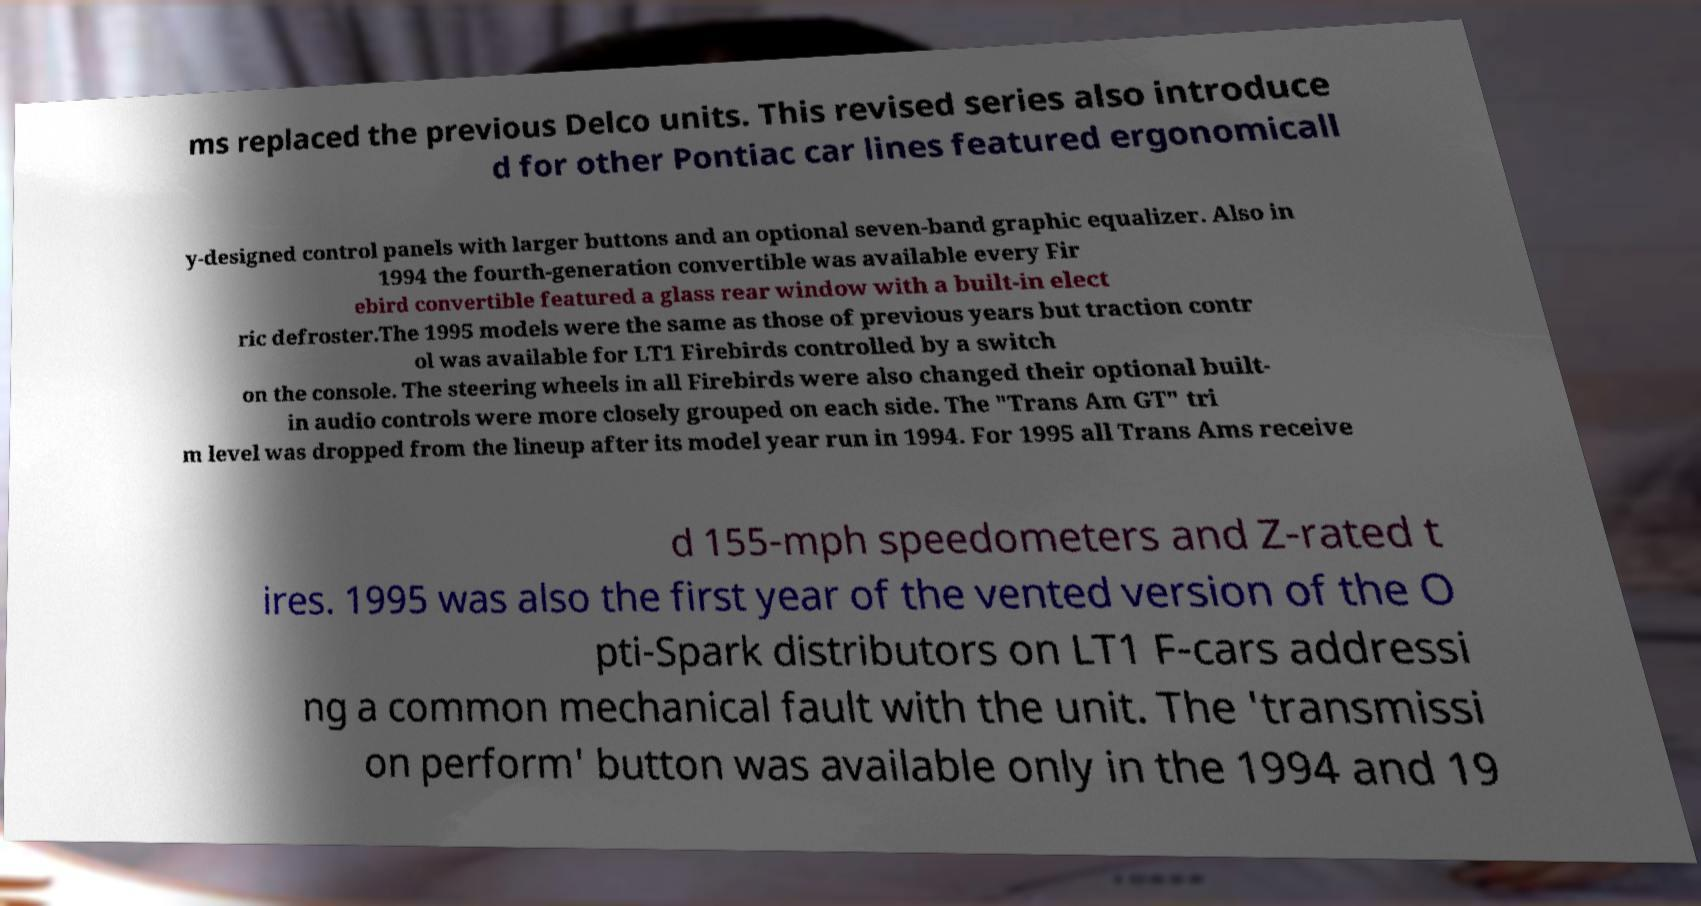Can you accurately transcribe the text from the provided image for me? ms replaced the previous Delco units. This revised series also introduce d for other Pontiac car lines featured ergonomicall y-designed control panels with larger buttons and an optional seven-band graphic equalizer. Also in 1994 the fourth-generation convertible was available every Fir ebird convertible featured a glass rear window with a built-in elect ric defroster.The 1995 models were the same as those of previous years but traction contr ol was available for LT1 Firebirds controlled by a switch on the console. The steering wheels in all Firebirds were also changed their optional built- in audio controls were more closely grouped on each side. The "Trans Am GT" tri m level was dropped from the lineup after its model year run in 1994. For 1995 all Trans Ams receive d 155-mph speedometers and Z-rated t ires. 1995 was also the first year of the vented version of the O pti-Spark distributors on LT1 F-cars addressi ng a common mechanical fault with the unit. The 'transmissi on perform' button was available only in the 1994 and 19 